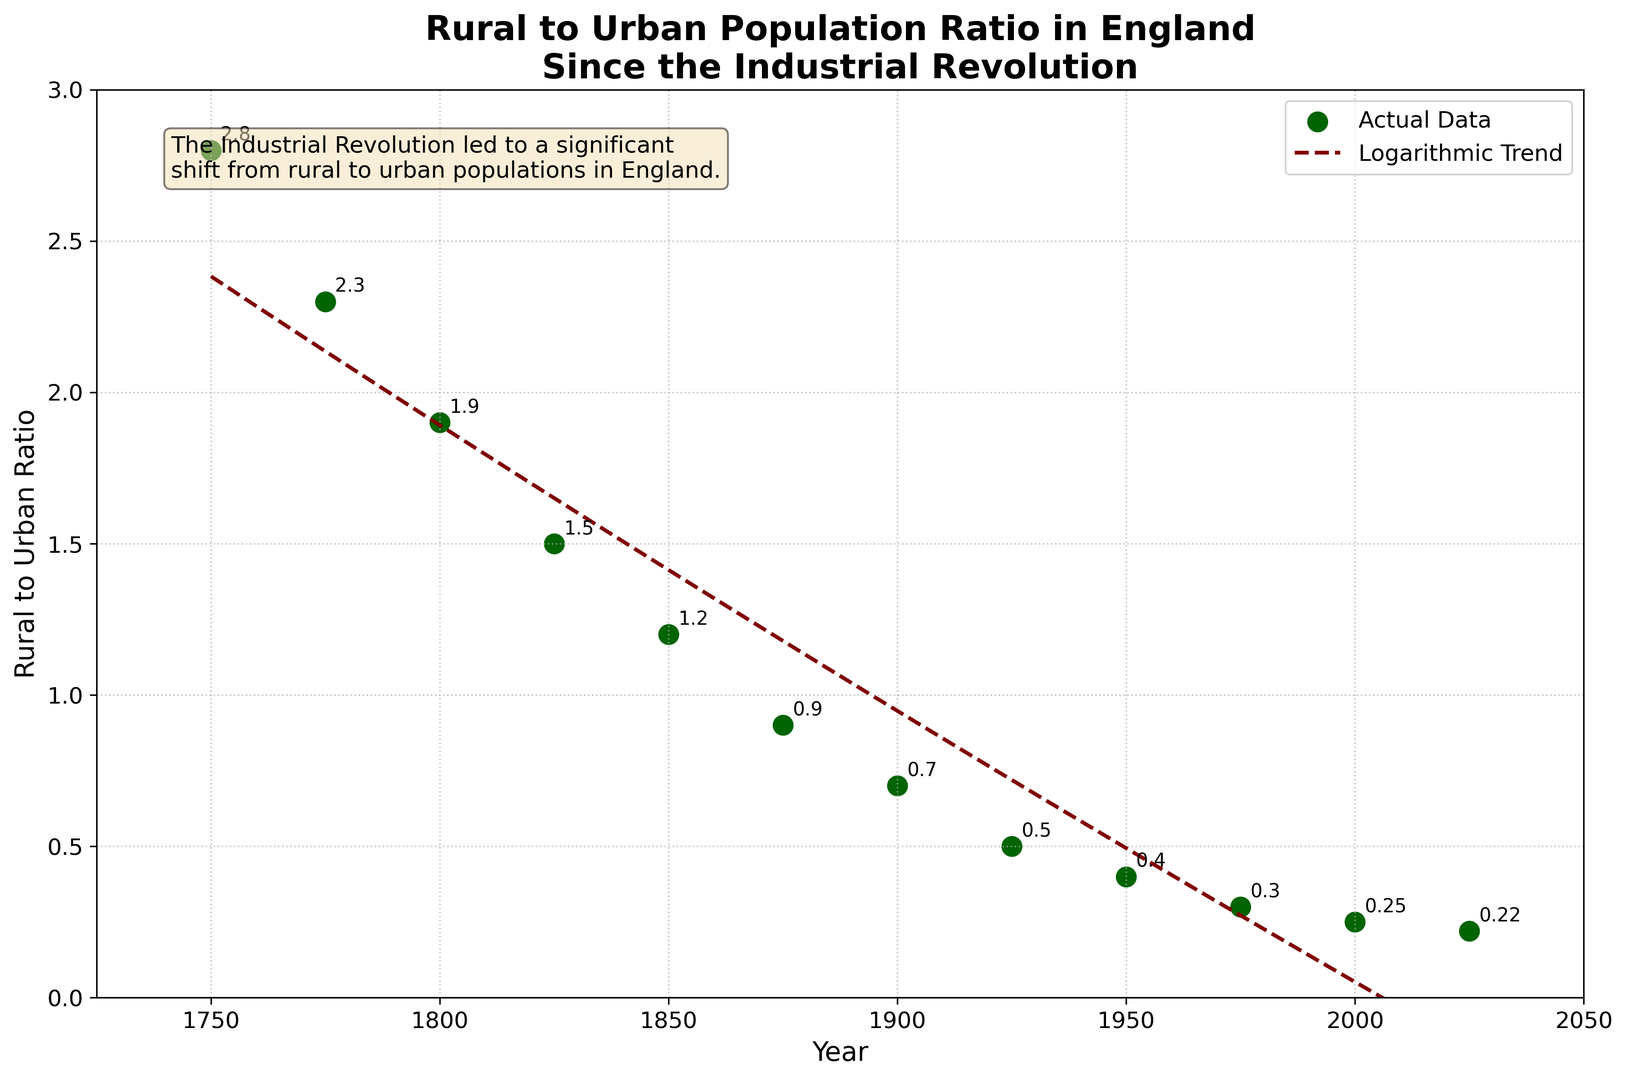When did the rural to urban population ratio drop below 1? By looking at the plotted points, we see that the ratio drops below 1 for the first time around the year 1875. A detailed check of the data confirms this.
Answer: 1875 By what percentage did the rural to urban population ratio decrease from 1750 to 1800? The ratio in 1750 was 2.8 and in 1800 it was 1.9. The percentage decrease is calculated as ((2.8 - 1.9) / 2.8) * 100. Breaking this down: 2.8 - 1.9 = 0.9, 0.9 / 2.8 = 0.3214, and 0.3214 * 100 ≈ 32.14%.
Answer: 32.14% Compare the rural to urban population ratio changes between the periods 1825-1850 and 1925-1950. Which period saw a greater decrease? The changes are from 1.5 to 1.2 (1825-1850) and 0.5 to 0.4 (1925-1950). The differences are 0.3 and 0.1 respectively. Therefore, the period 1825-1850 saw a greater decrease.
Answer: 1825-1850 What color represents the actual data points on the plot? Observing the plot shows the actual data points are marked with circles that are dark green in color.
Answer: Dark green Estimate the rural to urban population ratio in the year 2050 based on the logarithmic trend line. By extending the logarithmic trend line on the plot to the year 2050, we estimate the population ratio to be around 0.2.
Answer: 0.2 Which year had the highest rural to urban population ratio observed in the plot? Based on the scatter plot, the highest ratio observed is in the year 1750 with a value of 2.8.
Answer: 1750 Calculate the average rural to urban population ratio over the period from 1900 to 2000. Sum the ratios from the years 1900 (0.7), 1925 (0.5), 1950 (0.4), 1975 (0.3), and 2000 (0.25). The sum is 0.7 + 0.5 + 0.4 + 0.3 + 0.25 = 2.15. Divide by the number of years, 2.15 / 5 = 0.43.
Answer: 0.43 What is the ratio in the mid-19th century, and how does it compare to that in the late-20th century? The ratio in 1850 is 1.2, and the ratio in 1975 is 0.3. Comparing them, the mid-19th century ratio is significantly higher than the late-20th century ratio.
Answer: Mid-19th century ratio is higher Which annotation provides historical context on the plot? The text box at the top right contains the annotation "The Industrial Revolution led to a significant shift from rural to urban populations in England."
Answer: Industrial Revolution text box In which time frame did the rural to urban population ratio drop from above 1 to below 0.5? The ratio was above 1 in 1850 (1.2) and below 0.5 by 1925 (0.5). So, the significant drop happened between 1850 and 1925.
Answer: 1850-1925 